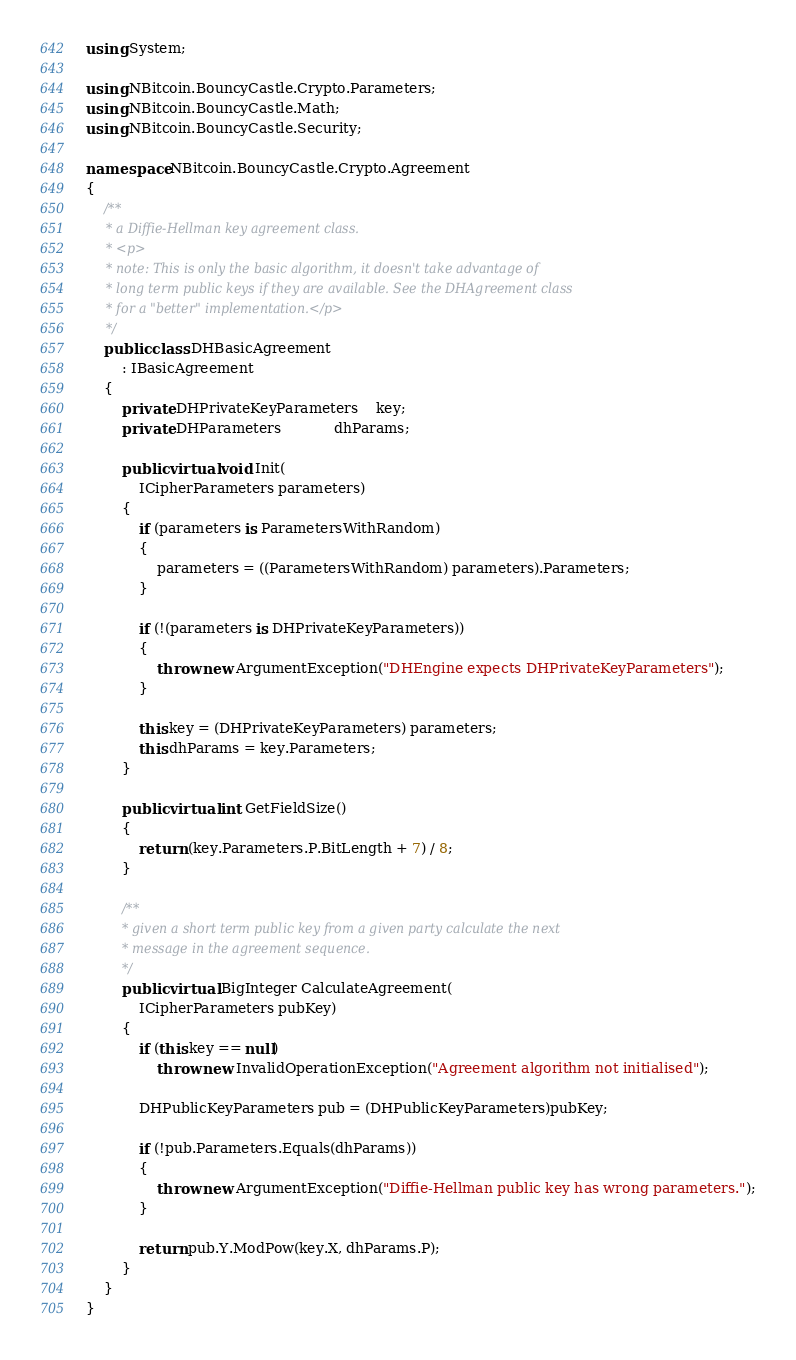Convert code to text. <code><loc_0><loc_0><loc_500><loc_500><_C#_>using System;

using NBitcoin.BouncyCastle.Crypto.Parameters;
using NBitcoin.BouncyCastle.Math;
using NBitcoin.BouncyCastle.Security;

namespace NBitcoin.BouncyCastle.Crypto.Agreement
{
    /**
     * a Diffie-Hellman key agreement class.
     * <p>
     * note: This is only the basic algorithm, it doesn't take advantage of
     * long term public keys if they are available. See the DHAgreement class
     * for a "better" implementation.</p>
     */
    public class DHBasicAgreement
        : IBasicAgreement
    {
        private DHPrivateKeyParameters	key;
        private DHParameters			dhParams;

        public virtual void Init(
            ICipherParameters parameters)
        {
            if (parameters is ParametersWithRandom)
            {
                parameters = ((ParametersWithRandom) parameters).Parameters;
            }

            if (!(parameters is DHPrivateKeyParameters))
            {
                throw new ArgumentException("DHEngine expects DHPrivateKeyParameters");
            }

            this.key = (DHPrivateKeyParameters) parameters;
            this.dhParams = key.Parameters;
        }

        public virtual int GetFieldSize()
        {
            return (key.Parameters.P.BitLength + 7) / 8;
        }

        /**
         * given a short term public key from a given party calculate the next
         * message in the agreement sequence.
         */
        public virtual BigInteger CalculateAgreement(
            ICipherParameters pubKey)
        {
            if (this.key == null)
                throw new InvalidOperationException("Agreement algorithm not initialised");

            DHPublicKeyParameters pub = (DHPublicKeyParameters)pubKey;

            if (!pub.Parameters.Equals(dhParams))
            {
                throw new ArgumentException("Diffie-Hellman public key has wrong parameters.");
            }

            return pub.Y.ModPow(key.X, dhParams.P);
        }
    }
}
</code> 